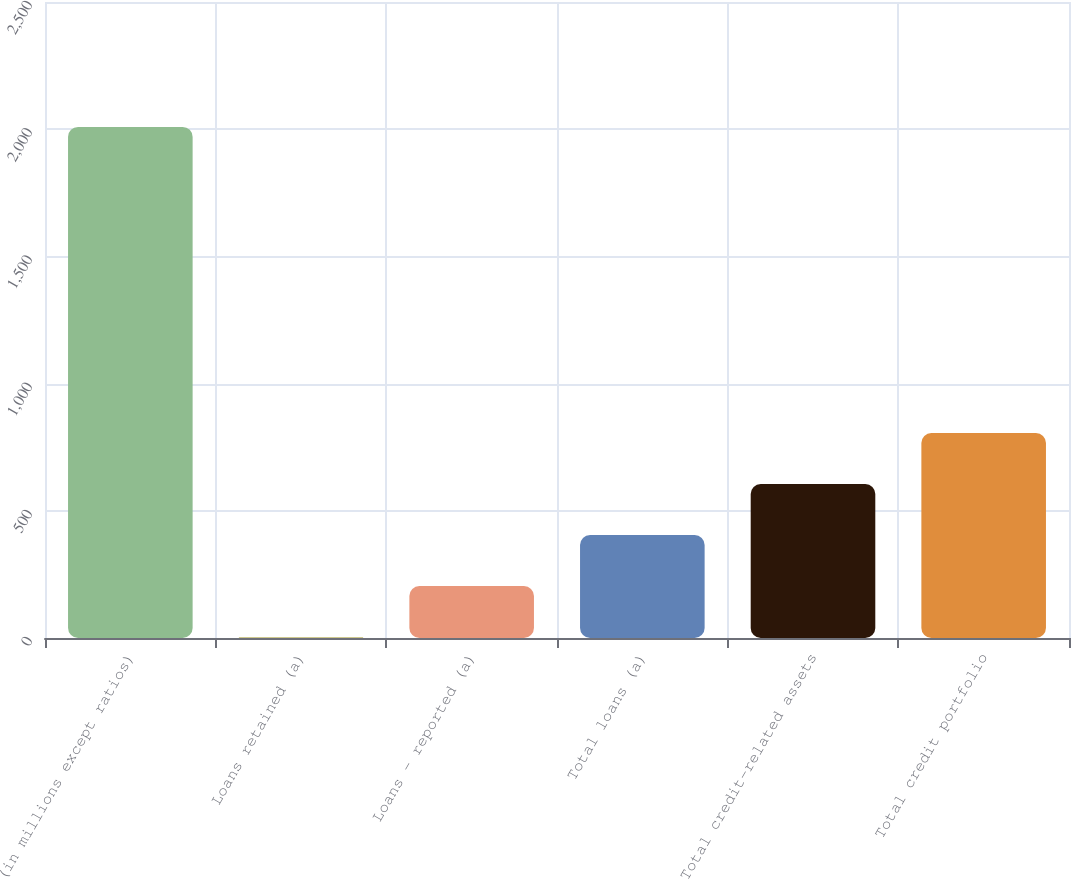Convert chart to OTSL. <chart><loc_0><loc_0><loc_500><loc_500><bar_chart><fcel>(in millions except ratios)<fcel>Loans retained (a)<fcel>Loans - reported (a)<fcel>Total loans (a)<fcel>Total credit-related assets<fcel>Total credit portfolio<nl><fcel>2009<fcel>3.42<fcel>203.98<fcel>404.54<fcel>605.1<fcel>805.66<nl></chart> 